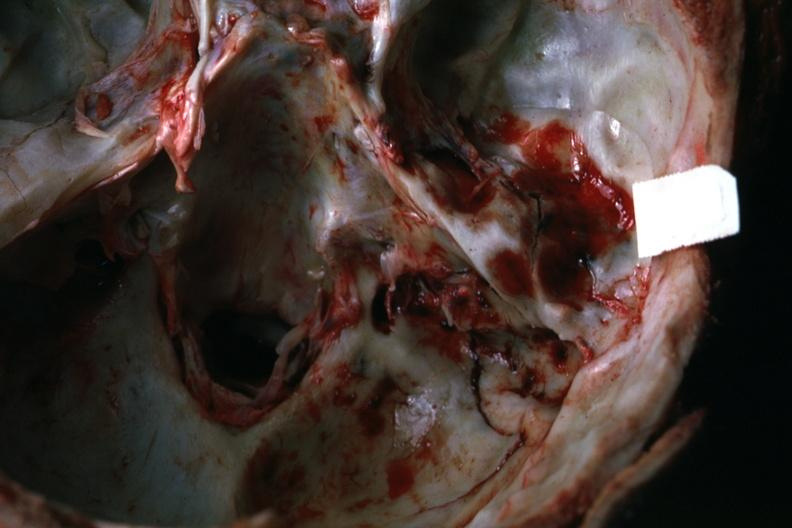does anencephaly show view of petrous portion temporal bone rather close-up 22yo man 37 foot fall?
Answer the question using a single word or phrase. No 